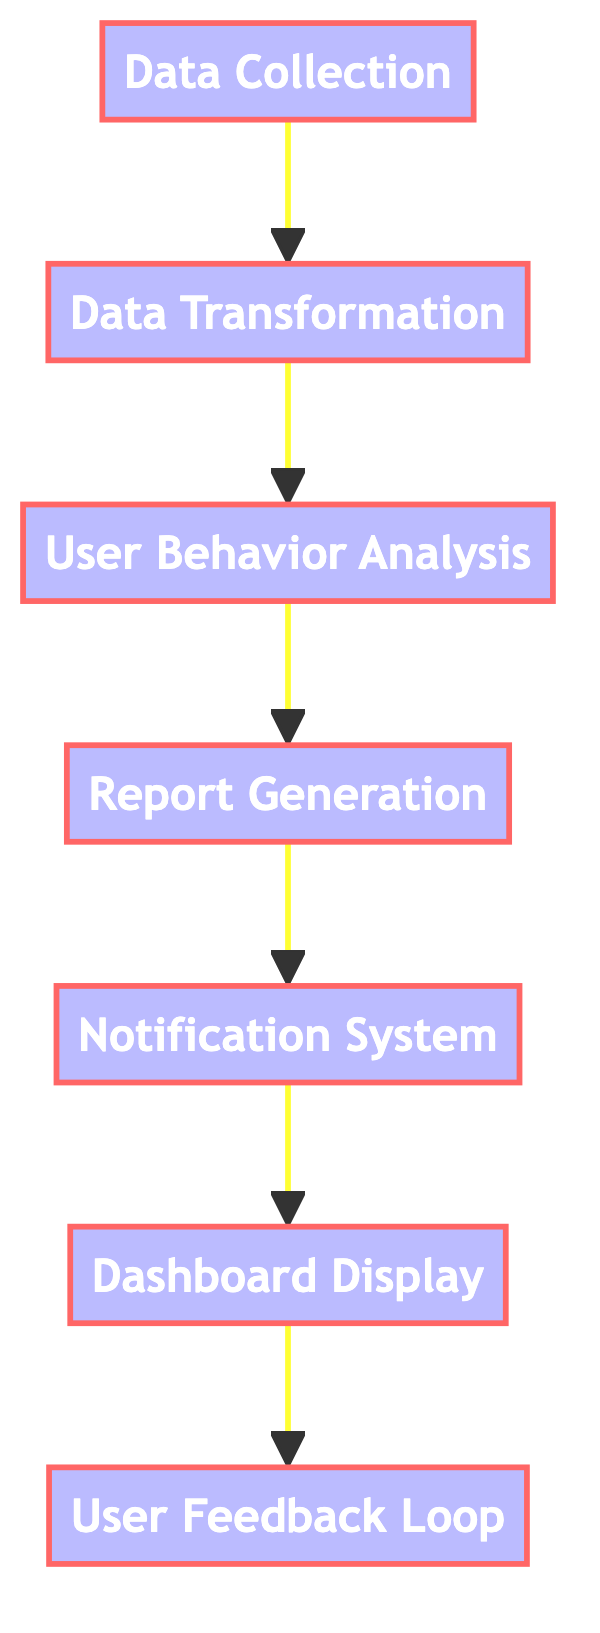What is the last process in the flow? The flowchart indicates a series of processes starting from data collection and ending with a user feedback loop. The last process depicted in the diagram, at the highest position, is the user feedback loop.
Answer: user feedback loop How many processes are illustrated in the diagram? Counting all the distinct processes that appear in the diagram, there are a total of seven processes shown: Data Collection, Data Transformation, User Behavior Analysis, Report Generation, Notification System, Dashboard Display, and User Feedback Loop.
Answer: seven What directly follows the Report Generation process? In the flowchart, after the report generation process, the next process shown in sequence is the notification system. Therefore, the notification system is the immediate next step after report generation.
Answer: notification system Which process comes before User Behavior Analysis? The diagram shows that before reaching user behavior analysis, the flow comes from data transformation. Thus, data transformation is the process that precedes user behavior analysis.
Answer: data transformation What is the function of the Notification System? According to the flowchart, the notification system is designed to alert stakeholders about significant usage events or anomalies in the cloud storage system.
Answer: alert stakeholders What is the primary goal of the User Feedback Loop? The user feedback loop's main objective, as described in the flowchart, is to incorporate user feedback for the continuous improvement of the monitoring and reporting functions.
Answer: continuous improvement Which two processes are connected directly before the Dashboard Display? The flowchart indicates that the notification system connects directly to the dashboard display, showing the sequence where the latter follows the former without any other process in between.
Answer: notification system and dashboard display What type of process does the Data Transformation represent? The diagram categorizes data transformation as a process, which is essential for converting and normalizing raw data into a format suitable for analysis.
Answer: process 